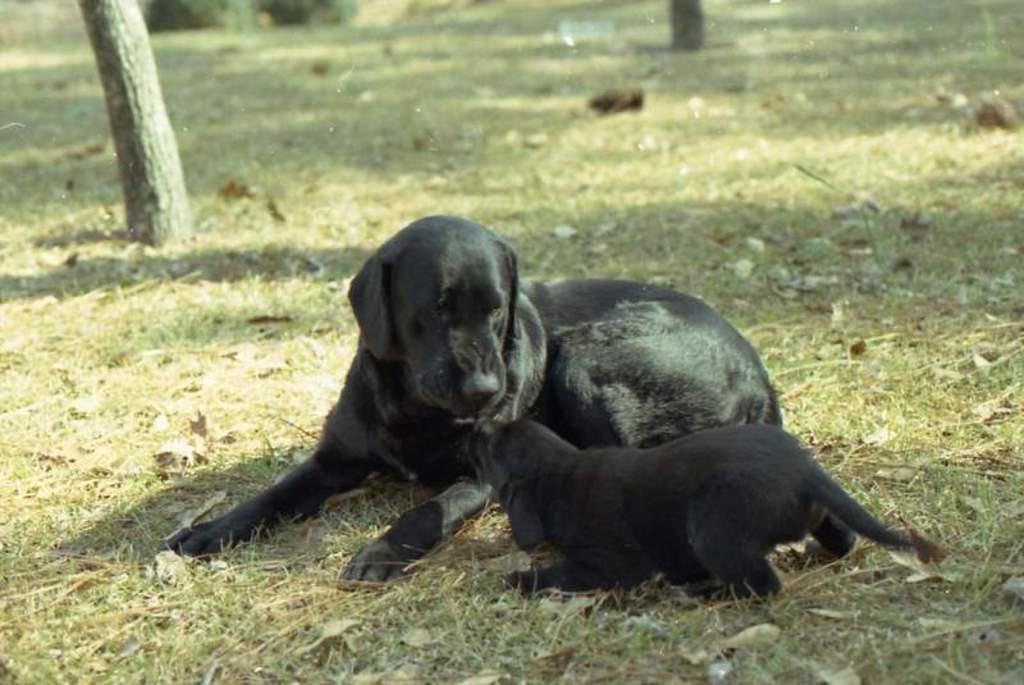Could you give a brief overview of what you see in this image? In the image we can see there is a black colour dog sitting on the ground and in front of the dog there is a black colour puppy. The ground is covered with grass. 